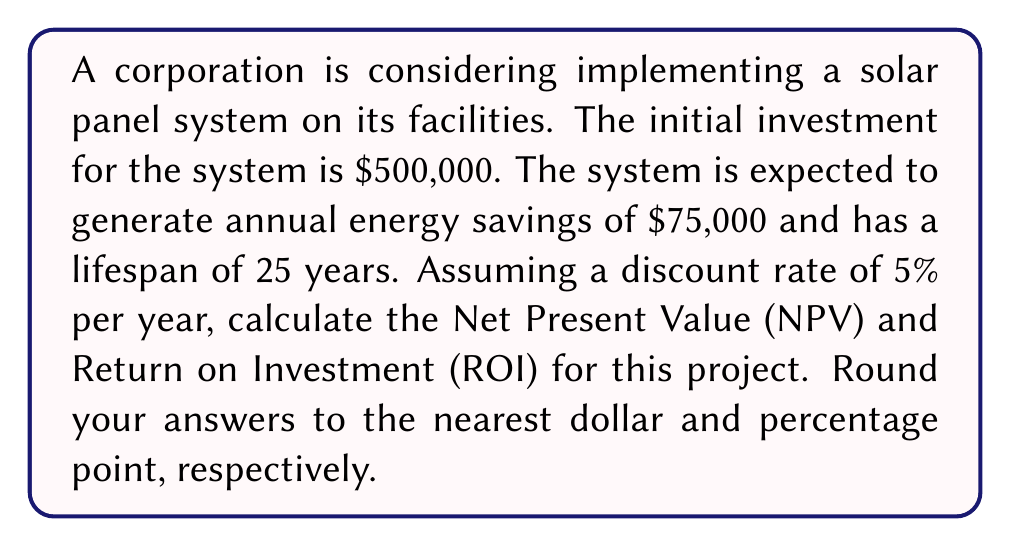What is the answer to this math problem? To solve this problem, we need to follow these steps:

1. Calculate the Present Value (PV) of future cash flows:
   The annual energy savings can be treated as an annuity. We use the present value of annuity formula:

   $$PV = A \cdot \frac{1 - (1 + r)^{-n}}{r}$$

   Where:
   $A$ = Annual cash flow (energy savings) = $75,000
   $r$ = Discount rate = 5% = 0.05
   $n$ = Number of years = 25

   $$PV = 75,000 \cdot \frac{1 - (1 + 0.05)^{-25}}{0.05} = 1,046,038$$

2. Calculate the Net Present Value (NPV):
   NPV is the difference between the present value of cash inflows and the initial investment.

   $$NPV = PV - \text{Initial Investment}$$
   $$NPV = 1,046,038 - 500,000 = 546,038$$

3. Calculate the Return on Investment (ROI):
   ROI is calculated as the ratio of the net profit (NPV) to the cost of investment, expressed as a percentage.

   $$ROI = \frac{NPV}{\text{Initial Investment}} \times 100\%$$
   $$ROI = \frac{546,038}{500,000} \times 100\% = 109.21\%$$

Rounding to the nearest dollar for NPV and nearest percentage point for ROI, we get:
NPV = $546,038
ROI = 109%
Answer: NPV = $546,038, ROI = 109% 